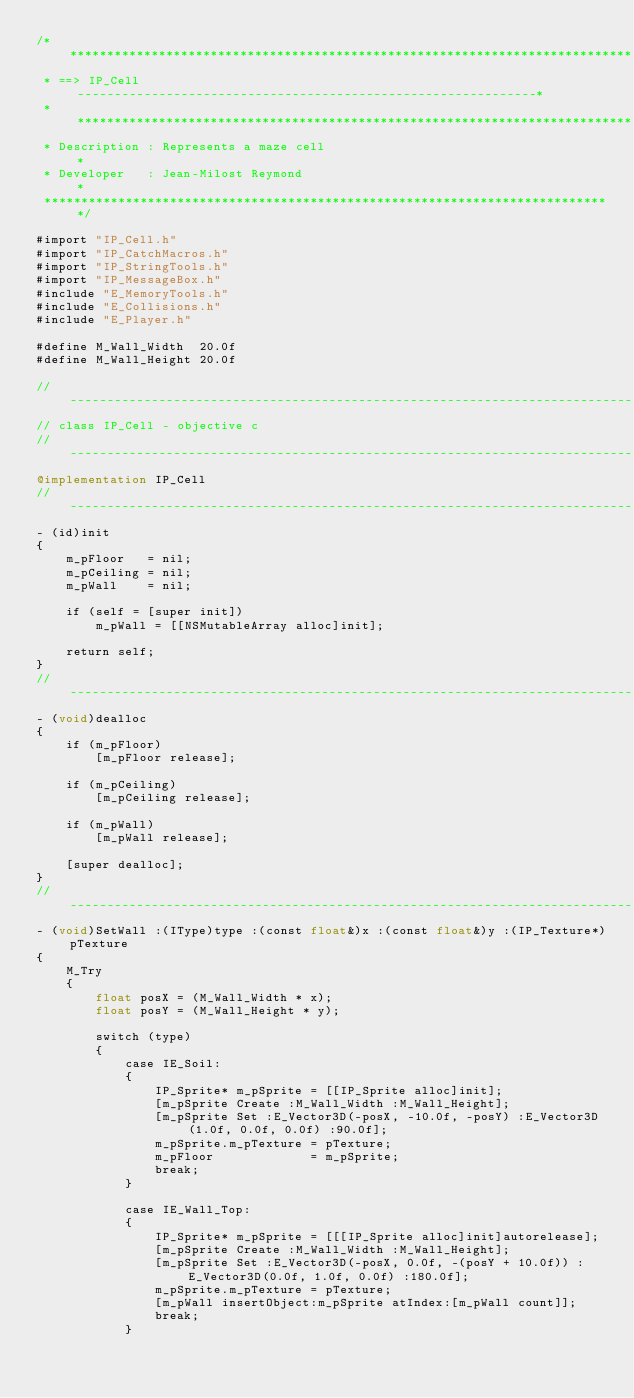<code> <loc_0><loc_0><loc_500><loc_500><_ObjectiveC_>/*****************************************************************************
 * ==> IP_Cell --------------------------------------------------------------*
 * ***************************************************************************
 * Description : Represents a maze cell                                      *
 * Developer   : Jean-Milost Reymond                                         *
 *****************************************************************************/

#import "IP_Cell.h"
#import "IP_CatchMacros.h"
#import "IP_StringTools.h"
#import "IP_MessageBox.h"
#include "E_MemoryTools.h"
#include "E_Collisions.h"
#include "E_Player.h"

#define M_Wall_Width  20.0f
#define M_Wall_Height 20.0f

//------------------------------------------------------------------------------
// class IP_Cell - objective c
//------------------------------------------------------------------------------
@implementation IP_Cell
//------------------------------------------------------------------------------
- (id)init
{
    m_pFloor   = nil;
    m_pCeiling = nil;
    m_pWall    = nil;

    if (self = [super init])
        m_pWall = [[NSMutableArray alloc]init];

    return self;
}
//-----------------------------------------------------------------------------
- (void)dealloc
{
    if (m_pFloor)
        [m_pFloor release];

    if (m_pCeiling)
        [m_pCeiling release];

    if (m_pWall)
        [m_pWall release];

    [super dealloc];
}
//------------------------------------------------------------------------------
- (void)SetWall :(IType)type :(const float&)x :(const float&)y :(IP_Texture*)pTexture
{
    M_Try
    {
        float posX = (M_Wall_Width * x);
        float posY = (M_Wall_Height * y);

        switch (type)
        {
            case IE_Soil:
            {
                IP_Sprite* m_pSprite = [[IP_Sprite alloc]init];
                [m_pSprite Create :M_Wall_Width :M_Wall_Height];
                [m_pSprite Set :E_Vector3D(-posX, -10.0f, -posY) :E_Vector3D(1.0f, 0.0f, 0.0f) :90.0f];
                m_pSprite.m_pTexture = pTexture;
                m_pFloor             = m_pSprite;
                break;
            }

            case IE_Wall_Top:
            {
                IP_Sprite* m_pSprite = [[[IP_Sprite alloc]init]autorelease];
                [m_pSprite Create :M_Wall_Width :M_Wall_Height];
                [m_pSprite Set :E_Vector3D(-posX, 0.0f, -(posY + 10.0f)) :E_Vector3D(0.0f, 1.0f, 0.0f) :180.0f];
                m_pSprite.m_pTexture = pTexture;
                [m_pWall insertObject:m_pSprite atIndex:[m_pWall count]];
                break;
            }</code> 